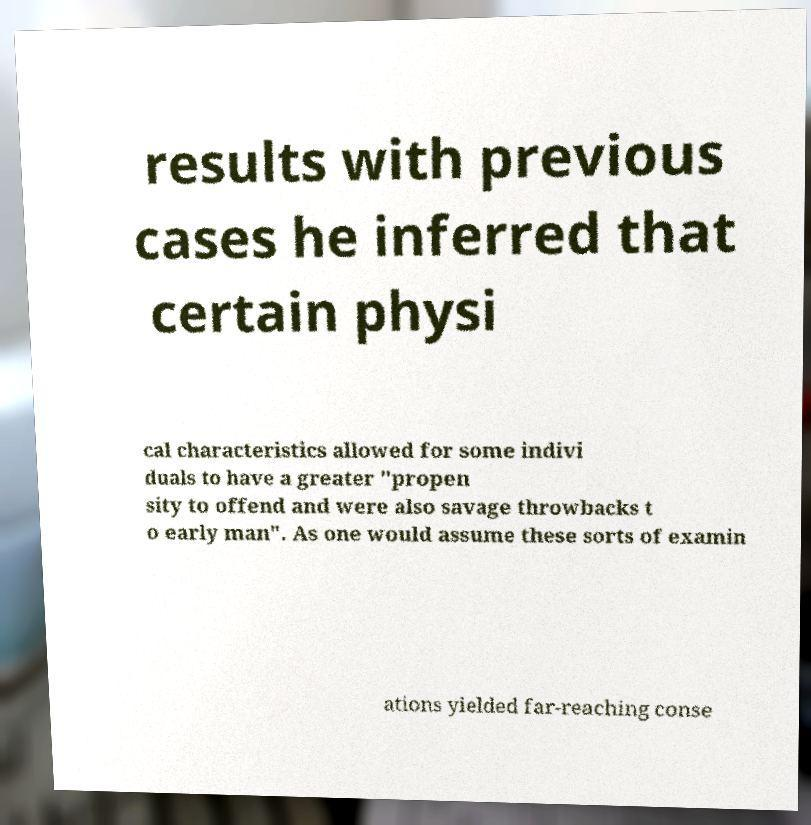What messages or text are displayed in this image? I need them in a readable, typed format. results with previous cases he inferred that certain physi cal characteristics allowed for some indivi duals to have a greater "propen sity to offend and were also savage throwbacks t o early man". As one would assume these sorts of examin ations yielded far-reaching conse 